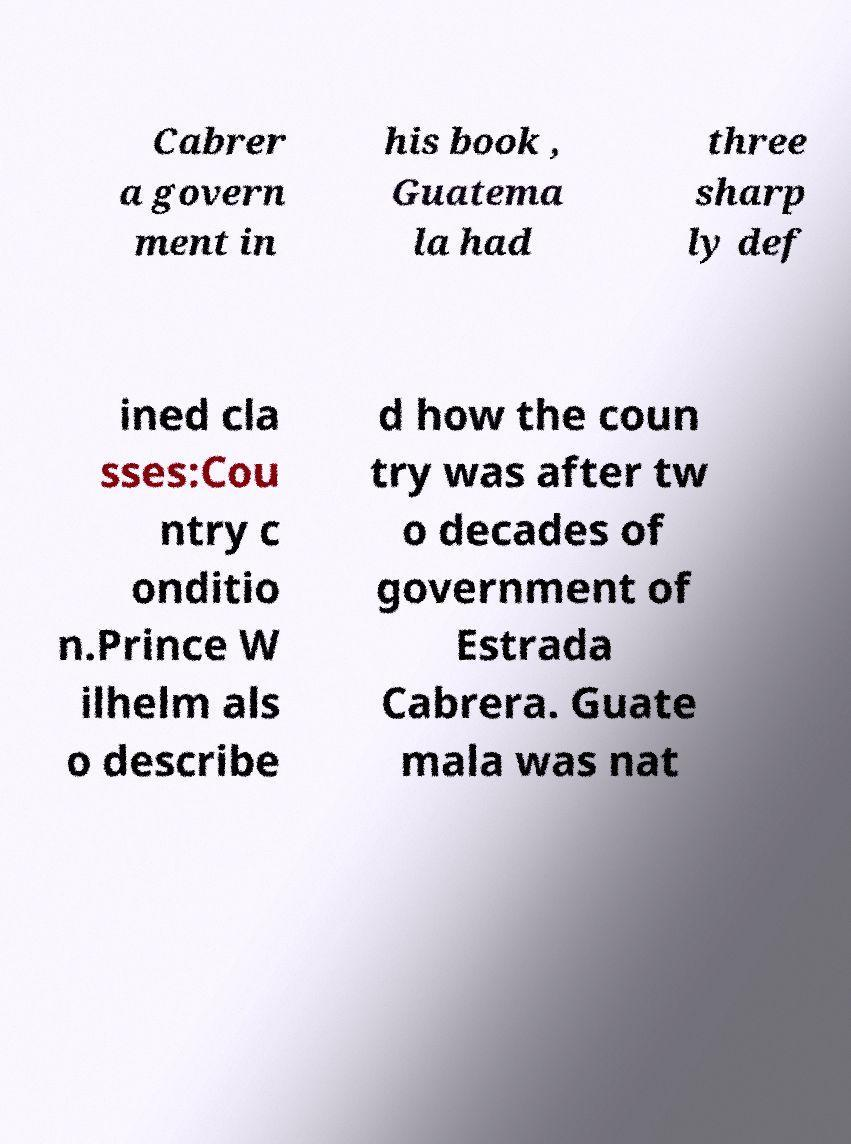There's text embedded in this image that I need extracted. Can you transcribe it verbatim? Cabrer a govern ment in his book , Guatema la had three sharp ly def ined cla sses:Cou ntry c onditio n.Prince W ilhelm als o describe d how the coun try was after tw o decades of government of Estrada Cabrera. Guate mala was nat 